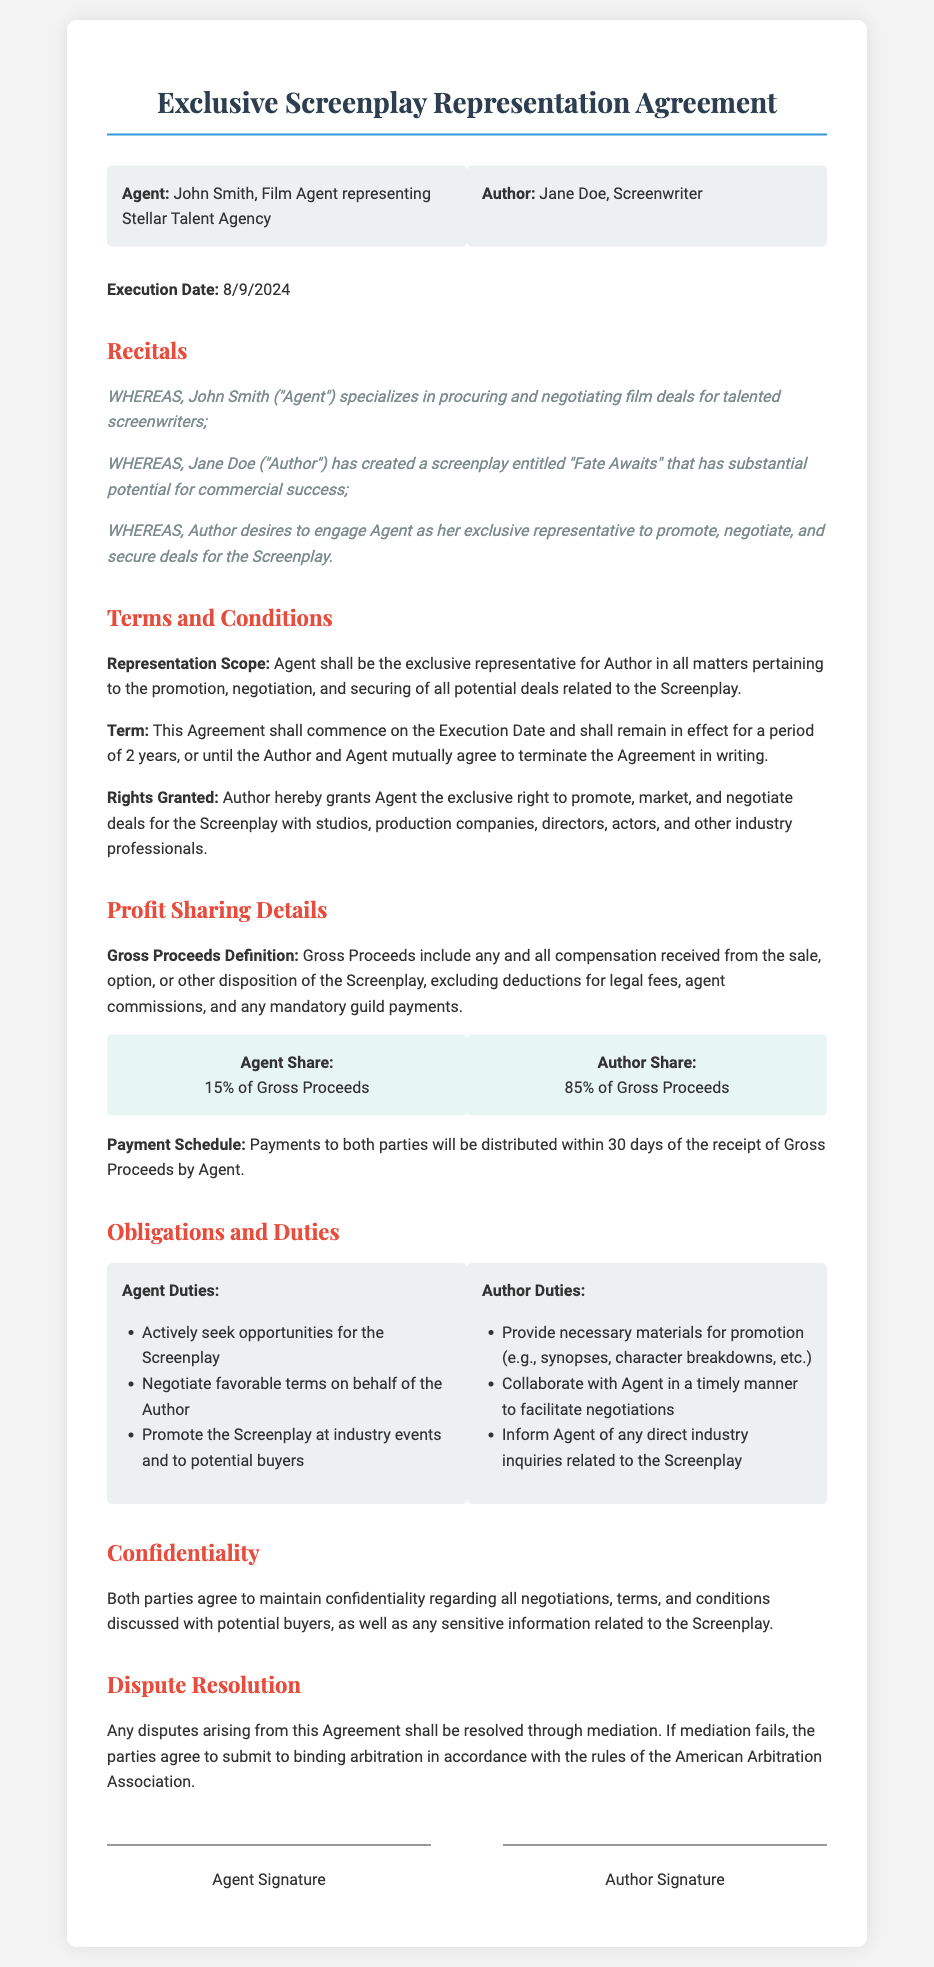What is the name of the Agent? The Agent's name is specified in the document as John Smith.
Answer: John Smith What is the name of the Author? The Author's name is specified as Jane Doe in the document.
Answer: Jane Doe How long is the term of the Agreement? The Agreement states that it remains in effect for a period of 2 years.
Answer: 2 years What percentage of Gross Proceeds does the Agent receive? The document specifies that the Agent share is 15% of Gross Proceeds.
Answer: 15% What is the payment schedule for distributions? The payment schedule indicates payments will be distributed within 30 days of receipt.
Answer: 30 days What is the title of the screenplay? The screenplay is titled "Fate Awaits" as stated in the recitals.
Answer: Fate Awaits What is the primary dispute resolution method mentioned? The primary dispute resolution method specified in the document is mediation.
Answer: Mediation What obligation does the Author have regarding promotion materials? The obligation is to provide necessary materials for promotion like synopses.
Answer: Provide materials What is the Agent's duty regarding negotiation? The Agent's duty is to negotiate favorable terms on behalf of the Author.
Answer: Negotiate favorable terms 